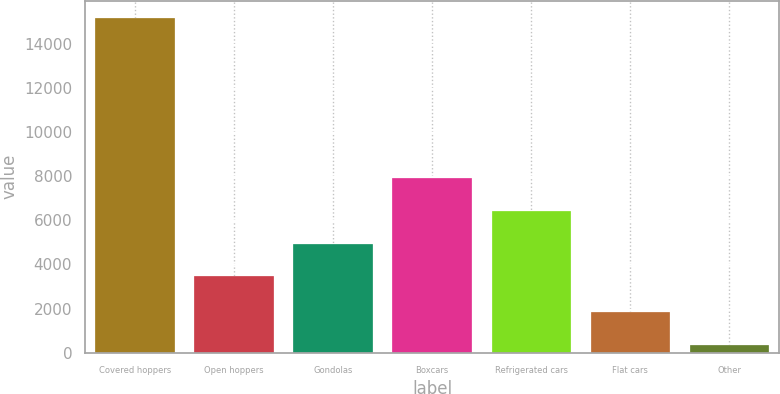Convert chart. <chart><loc_0><loc_0><loc_500><loc_500><bar_chart><fcel>Covered hoppers<fcel>Open hoppers<fcel>Gondolas<fcel>Boxcars<fcel>Refrigerated cars<fcel>Flat cars<fcel>Other<nl><fcel>15189<fcel>3464<fcel>4947.7<fcel>7915.1<fcel>6431.4<fcel>1835.7<fcel>352<nl></chart> 